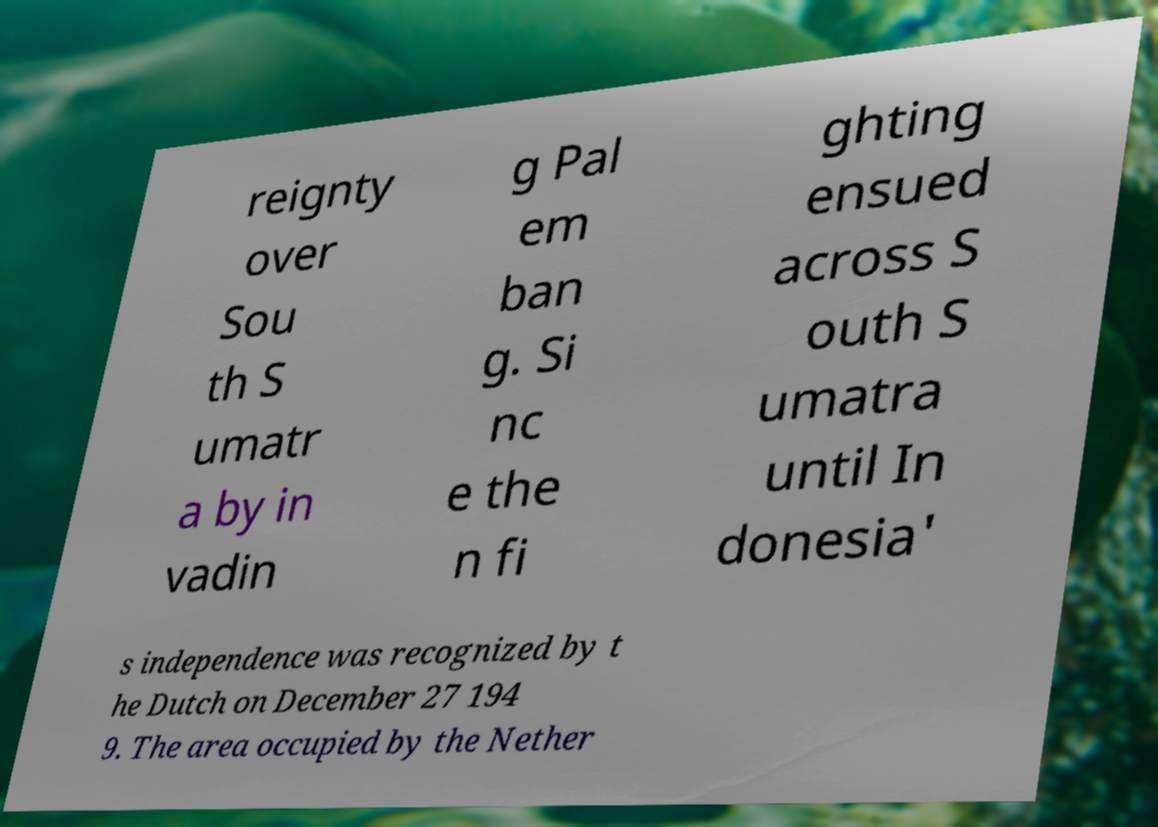I need the written content from this picture converted into text. Can you do that? reignty over Sou th S umatr a by in vadin g Pal em ban g. Si nc e the n fi ghting ensued across S outh S umatra until In donesia' s independence was recognized by t he Dutch on December 27 194 9. The area occupied by the Nether 